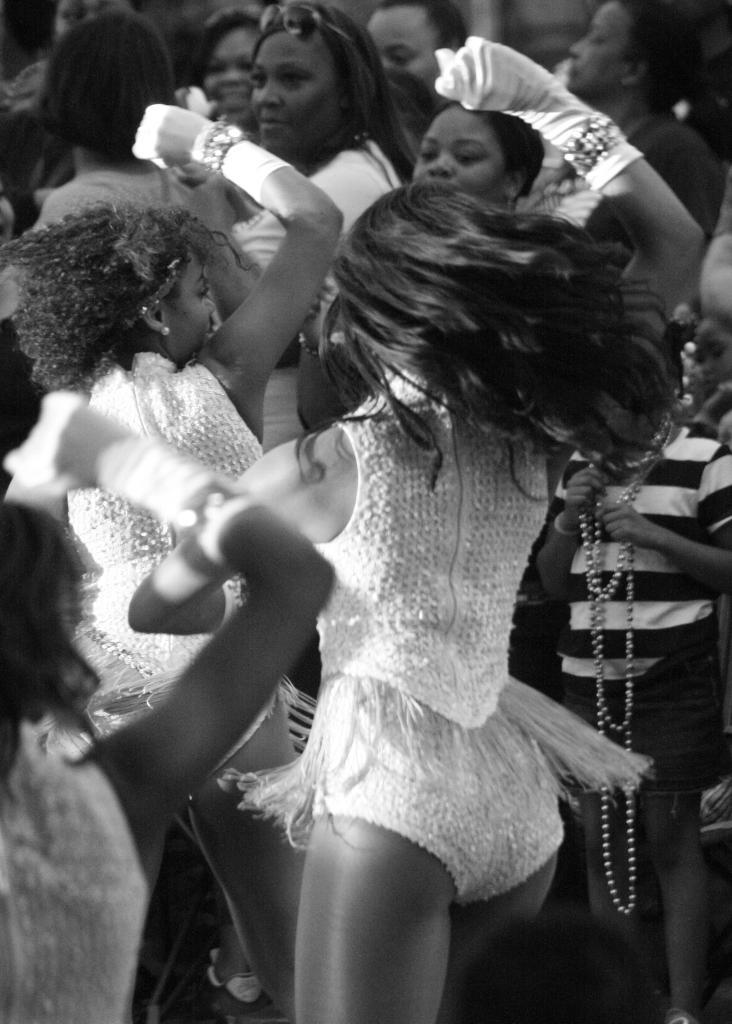What are the people in the image doing? There are people dancing in the image. Are there any other people in the image besides those dancing? Yes, there are people standing in the image. What type of apparatus is being used by the people to change their appearance in the image? There is no apparatus present in the image, and no one is changing their appearance. 